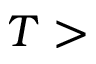<formula> <loc_0><loc_0><loc_500><loc_500>T ></formula> 